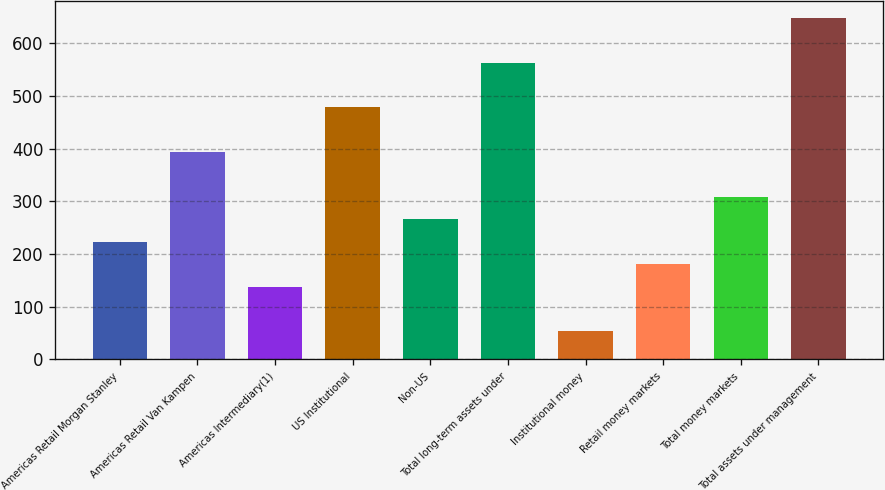<chart> <loc_0><loc_0><loc_500><loc_500><bar_chart><fcel>Americas Retail Morgan Stanley<fcel>Americas Retail Van Kampen<fcel>Americas Intermediary(1)<fcel>US Institutional<fcel>Non-US<fcel>Total long-term assets under<fcel>Institutional money<fcel>Retail money markets<fcel>Total money markets<fcel>Total assets under management<nl><fcel>223.5<fcel>393.5<fcel>138.5<fcel>478.5<fcel>266<fcel>563.5<fcel>53.5<fcel>181<fcel>308.5<fcel>648.5<nl></chart> 